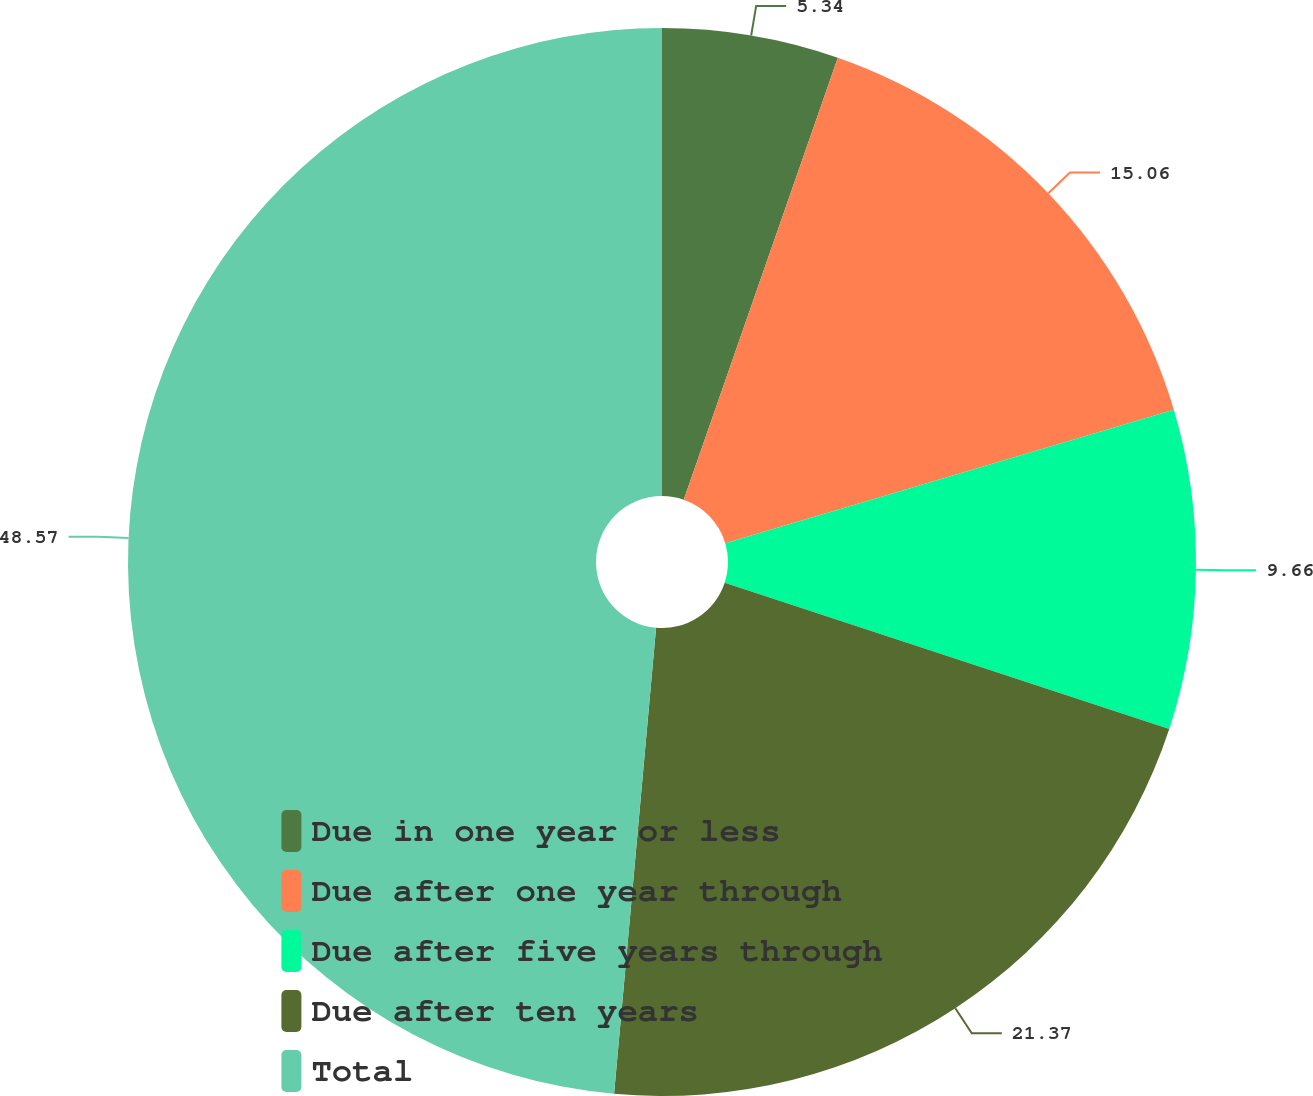Convert chart. <chart><loc_0><loc_0><loc_500><loc_500><pie_chart><fcel>Due in one year or less<fcel>Due after one year through<fcel>Due after five years through<fcel>Due after ten years<fcel>Total<nl><fcel>5.34%<fcel>15.06%<fcel>9.66%<fcel>21.37%<fcel>48.57%<nl></chart> 